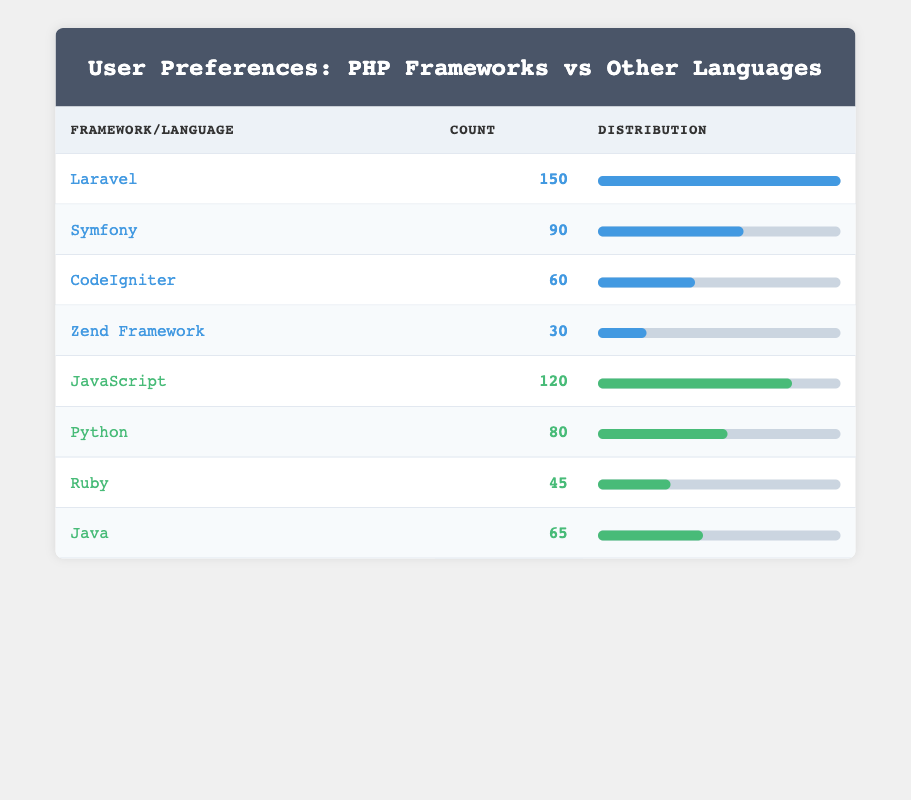What is the count for Laravel? The table indicates that the count for Laravel is listed in the respective row under the "Count" column, which shows a value of 150.
Answer: 150 Which framework has the highest preference count? By reviewing the counts listed for each framework, Laravel has the highest count of 150, which is more than any other framework present in the table.
Answer: Laravel What is the total count of users who prefer PHP frameworks? To find the total count of users who prefer PHP frameworks, add the counts of Laravel, Symfony, CodeIgniter, and Zend Framework: 150 + 90 + 60 + 30 = 330.
Answer: 330 Which programming language has a higher count, Java or Ruby? Checking the table reveals Java has a count of 65 and Ruby has a count of 45. Since 65 is greater than 45, Java has a higher count.
Answer: Java Is the total count of users for JavaScript greater than the total count of users for PHP frameworks? From the totals calculated previously, the count for JavaScript is 120, and the total for PHP frameworks is 330. Since 120 is less than 330, the answer is no.
Answer: No What is the average count for all programming languages listed? To find the average, first sum the counts for JavaScript, Python, Ruby, and Java: 120 + 80 + 45 + 65 = 310. Since there are 4 programming languages, divide the total count (310) by 4 to get 310 / 4 = 77.5.
Answer: 77.5 How many more users prefer Laravel over Symfony? The count for Laravel is 150, and the count for Symfony is 90. The difference between them is calculated by subtracting the two counts: 150 - 90 = 60.
Answer: 60 What proportion of users prefer CodeIgniter compared to all PHP framework users? First, we calculate the total count of PHP framework users, which is 330. CodeIgniter has a count of 60. To find the proportion, divide the count for CodeIgniter by the total PHP framework count: 60 / 330 = approximately 0.1818 or 18.18%.
Answer: 18.18% Are there more users preferring PHP frameworks in total than users preferring Python alone? The total count of PHP frameworks is 330, while the count for Python is 80. Since 330 is greater than 80, the answer is yes.
Answer: Yes 